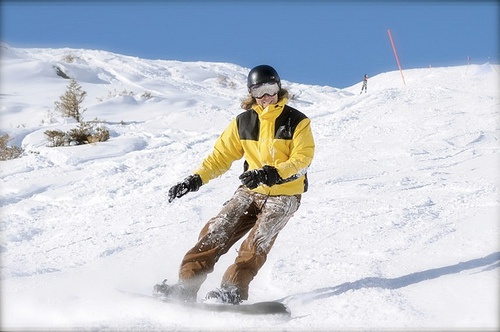Describe the objects in this image and their specific colors. I can see people in darkblue, darkgray, lightgray, black, and gray tones, snowboard in darkblue, lightgray, darkgray, and gray tones, and people in darkblue, darkgray, lightgray, and gray tones in this image. 